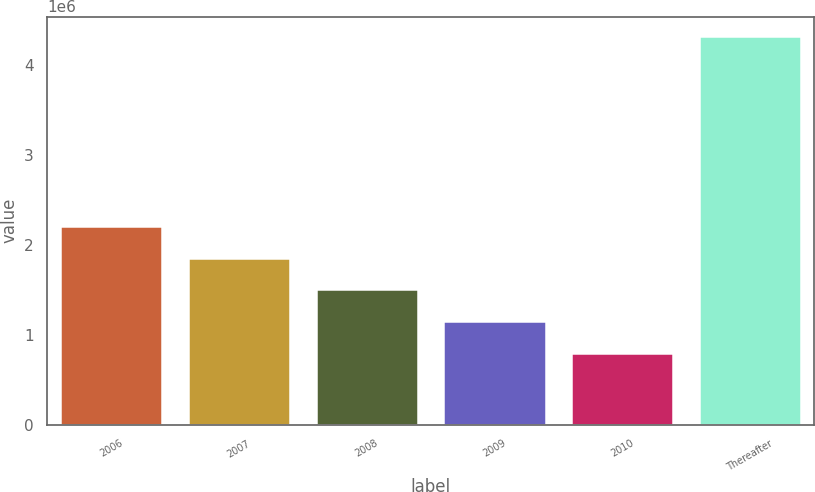Convert chart. <chart><loc_0><loc_0><loc_500><loc_500><bar_chart><fcel>2006<fcel>2007<fcel>2008<fcel>2009<fcel>2010<fcel>Thereafter<nl><fcel>2.20914e+06<fcel>1.85754e+06<fcel>1.50594e+06<fcel>1.15435e+06<fcel>802750<fcel>4.31872e+06<nl></chart> 